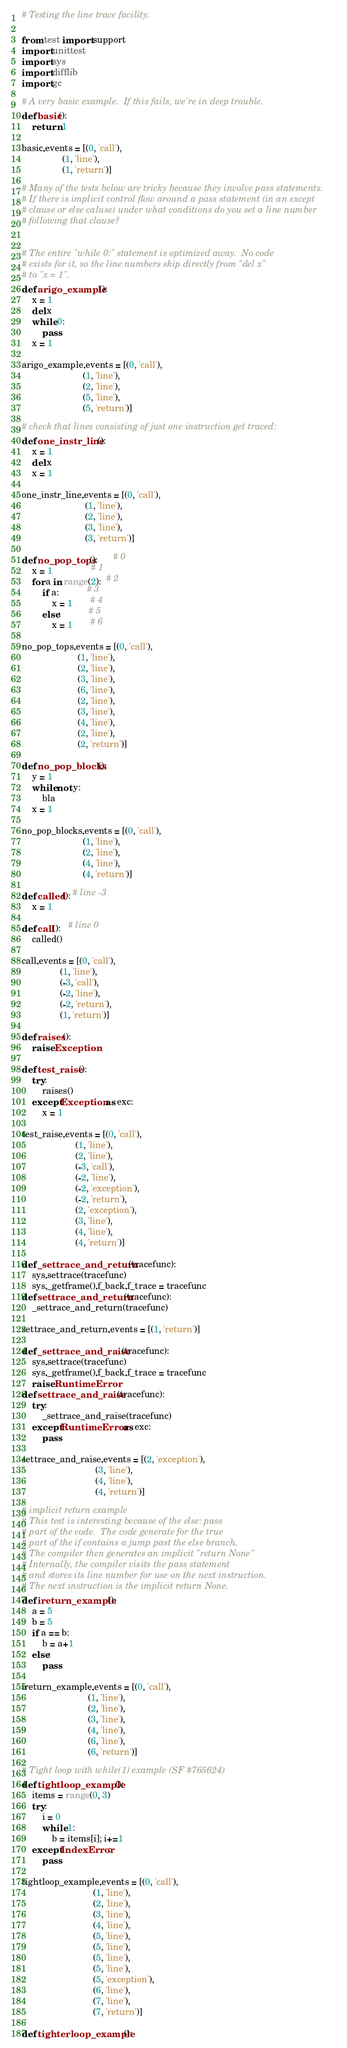<code> <loc_0><loc_0><loc_500><loc_500><_Python_># Testing the line trace facility.

from test import support
import unittest
import sys
import difflib
import gc

# A very basic example.  If this fails, we're in deep trouble.
def basic():
    return 1

basic.events = [(0, 'call'),
                (1, 'line'),
                (1, 'return')]

# Many of the tests below are tricky because they involve pass statements.
# If there is implicit control flow around a pass statement (in an except
# clause or else caluse) under what conditions do you set a line number
# following that clause?


# The entire "while 0:" statement is optimized away.  No code
# exists for it, so the line numbers skip directly from "del x"
# to "x = 1".
def arigo_example():
    x = 1
    del x
    while 0:
        pass
    x = 1

arigo_example.events = [(0, 'call'),
                        (1, 'line'),
                        (2, 'line'),
                        (5, 'line'),
                        (5, 'return')]

# check that lines consisting of just one instruction get traced:
def one_instr_line():
    x = 1
    del x
    x = 1

one_instr_line.events = [(0, 'call'),
                         (1, 'line'),
                         (2, 'line'),
                         (3, 'line'),
                         (3, 'return')]

def no_pop_tops():      # 0
    x = 1               # 1
    for a in range(2):  # 2
        if a:           # 3
            x = 1       # 4
        else:           # 5
            x = 1       # 6

no_pop_tops.events = [(0, 'call'),
                      (1, 'line'),
                      (2, 'line'),
                      (3, 'line'),
                      (6, 'line'),
                      (2, 'line'),
                      (3, 'line'),
                      (4, 'line'),
                      (2, 'line'),
                      (2, 'return')]

def no_pop_blocks():
    y = 1
    while not y:
        bla
    x = 1

no_pop_blocks.events = [(0, 'call'),
                        (1, 'line'),
                        (2, 'line'),
                        (4, 'line'),
                        (4, 'return')]

def called(): # line -3
    x = 1

def call():   # line 0
    called()

call.events = [(0, 'call'),
               (1, 'line'),
               (-3, 'call'),
               (-2, 'line'),
               (-2, 'return'),
               (1, 'return')]

def raises():
    raise Exception

def test_raise():
    try:
        raises()
    except Exception as exc:
        x = 1

test_raise.events = [(0, 'call'),
                     (1, 'line'),
                     (2, 'line'),
                     (-3, 'call'),
                     (-2, 'line'),
                     (-2, 'exception'),
                     (-2, 'return'),
                     (2, 'exception'),
                     (3, 'line'),
                     (4, 'line'),
                     (4, 'return')]

def _settrace_and_return(tracefunc):
    sys.settrace(tracefunc)
    sys._getframe().f_back.f_trace = tracefunc
def settrace_and_return(tracefunc):
    _settrace_and_return(tracefunc)

settrace_and_return.events = [(1, 'return')]

def _settrace_and_raise(tracefunc):
    sys.settrace(tracefunc)
    sys._getframe().f_back.f_trace = tracefunc
    raise RuntimeError
def settrace_and_raise(tracefunc):
    try:
        _settrace_and_raise(tracefunc)
    except RuntimeError as exc:
        pass

settrace_and_raise.events = [(2, 'exception'),
                             (3, 'line'),
                             (4, 'line'),
                             (4, 'return')]

# implicit return example
# This test is interesting because of the else: pass
# part of the code.  The code generate for the true
# part of the if contains a jump past the else branch.
# The compiler then generates an implicit "return None"
# Internally, the compiler visits the pass statement
# and stores its line number for use on the next instruction.
# The next instruction is the implicit return None.
def ireturn_example():
    a = 5
    b = 5
    if a == b:
        b = a+1
    else:
        pass

ireturn_example.events = [(0, 'call'),
                          (1, 'line'),
                          (2, 'line'),
                          (3, 'line'),
                          (4, 'line'),
                          (6, 'line'),
                          (6, 'return')]

# Tight loop with while(1) example (SF #765624)
def tightloop_example():
    items = range(0, 3)
    try:
        i = 0
        while 1:
            b = items[i]; i+=1
    except IndexError:
        pass

tightloop_example.events = [(0, 'call'),
                            (1, 'line'),
                            (2, 'line'),
                            (3, 'line'),
                            (4, 'line'),
                            (5, 'line'),
                            (5, 'line'),
                            (5, 'line'),
                            (5, 'line'),
                            (5, 'exception'),
                            (6, 'line'),
                            (7, 'line'),
                            (7, 'return')]

def tighterloop_example():</code> 